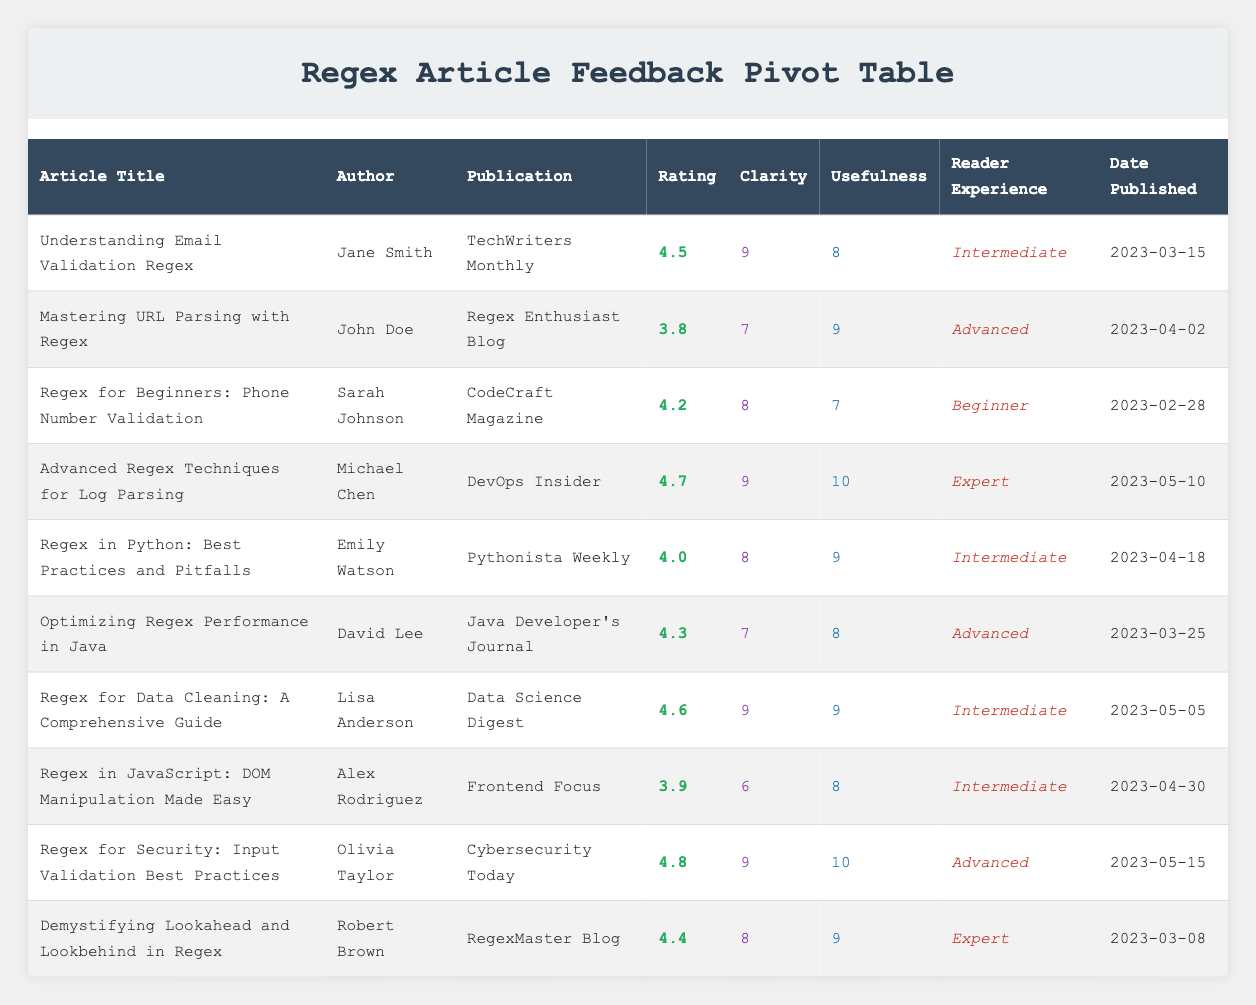What is the highest rating given to an article in the table? By scanning through the "Rating" column, we can see that the highest rating is 4.8, which corresponds to the article "Regex for Security: Input Validation Best Practices" by Olivia Taylor.
Answer: 4.8 Which article has the lowest clarity score? The "Clarity" scores are listed, and the lowest score is 6, associated with the article "Regex in JavaScript: DOM Manipulation Made Easy" by Alex Rodriguez.
Answer: 6 What are the average usefulness scores for articles aimed at Intermediate readers? The articles targeting Intermediate readers are "Understanding Email Validation Regex" (8), "Regex in Python: Best Practices and Pitfalls" (9), "Regex for Data Cleaning: A Comprehensive Guide" (9), and "Regex in JavaScript: DOM Manipulation Made Easy" (8), summing these scores gives 34. There are 4 articles, so the average usefulness score is 34/4 = 8.5.
Answer: 8.5 Is there an article authored by Sarah Johnson? Scanning through the "Author" column, we see that Sarah Johnson wrote the article "Regex for Beginners: Phone Number Validation." Therefore, the answer is yes.
Answer: Yes How many articles were published after April 1, 2023? By checking the "Date Published" column, we see that the articles published after April 1, 2023, are "Advanced Regex Techniques for Log Parsing," "Regex in Python: Best Practices and Pitfalls," "Regex for Data Cleaning: A Comprehensive Guide," "Regex for Security: Input Validation Best Practices," and "Demystifying Lookahead and Lookbehind in Regex." This totals 5 articles.
Answer: 5 Which article has the highest score for usefulness and who is the author? By looking at the "Usefulness" scores, "Advanced Regex Techniques for Log Parsing" has the highest score of 10, authored by Michael Chen.
Answer: Advanced Regex Techniques for Log Parsing by Michael Chen What is the difference between the highest and lowest clarity scores in the table? The highest clarity score is 9 from several articles, and the lowest is 6 from "Regex in JavaScript: DOM Manipulation Made Easy." The difference is calculated as 9 - 6 = 3.
Answer: 3 How many articles have a rating of 4.0 or higher? Evaluating the "Rating" column, the articles "Understanding Email Validation Regex" (4.5), "Regex for Beginners: Phone Number Validation" (4.2), "Advanced Regex Techniques for Log Parsing" (4.7), "Regex in Python: Best Practices and Pitfalls" (4.0), "Optimizing Regex Performance in Java" (4.3), "Regex for Data Cleaning: A Comprehensive Guide" (4.6), "Regex for Security: Input Validation Best Practices" (4.8), and "Demystifying Lookahead and Lookbehind in Regex" (4.4) have ratings of 4.0 or higher, totaling 8 articles.
Answer: 8 